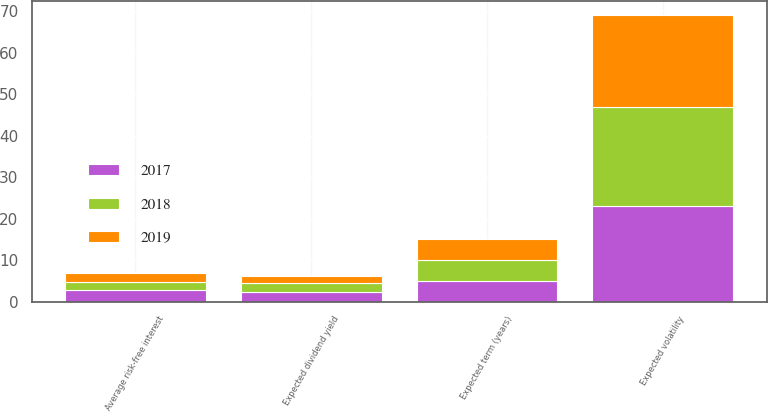Convert chart to OTSL. <chart><loc_0><loc_0><loc_500><loc_500><stacked_bar_chart><ecel><fcel>Average risk-free interest<fcel>Expected dividend yield<fcel>Expected volatility<fcel>Expected term (years)<nl><fcel>2017<fcel>2.79<fcel>2.27<fcel>23<fcel>5<nl><fcel>2019<fcel>2.14<fcel>1.75<fcel>22<fcel>5<nl><fcel>2018<fcel>1.85<fcel>2.21<fcel>24<fcel>5.1<nl></chart> 